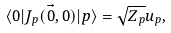<formula> <loc_0><loc_0><loc_500><loc_500>\langle 0 | J _ { p } ( \vec { 0 } , 0 ) | p \rangle = \sqrt { Z _ { p } } u _ { p } ,</formula> 